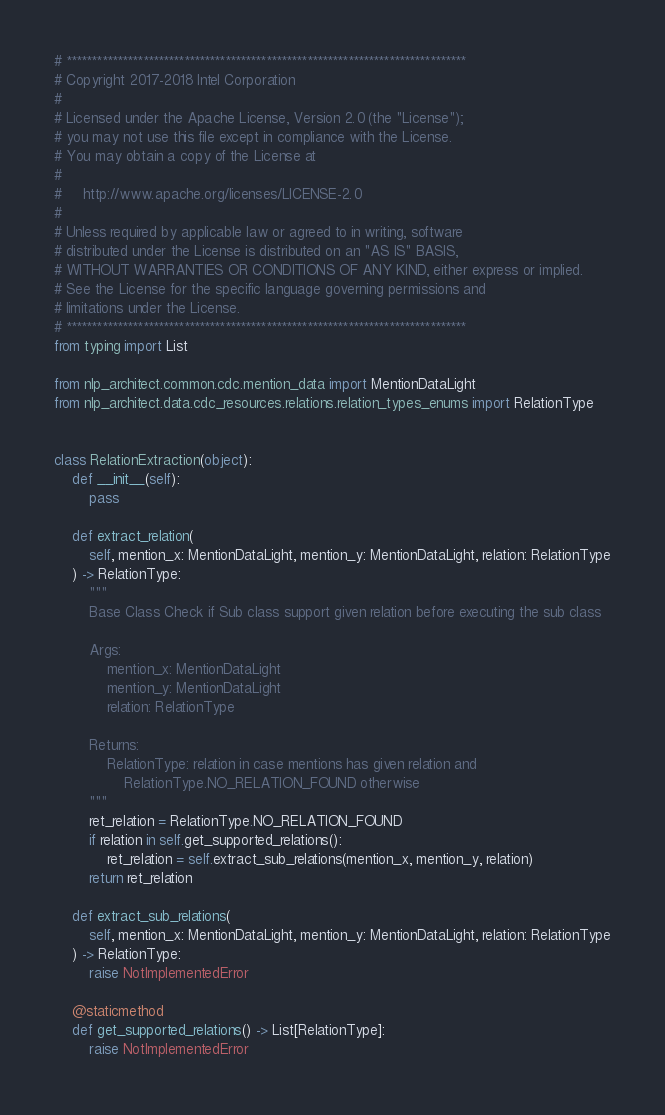Convert code to text. <code><loc_0><loc_0><loc_500><loc_500><_Python_># ******************************************************************************
# Copyright 2017-2018 Intel Corporation
#
# Licensed under the Apache License, Version 2.0 (the "License");
# you may not use this file except in compliance with the License.
# You may obtain a copy of the License at
#
#     http://www.apache.org/licenses/LICENSE-2.0
#
# Unless required by applicable law or agreed to in writing, software
# distributed under the License is distributed on an "AS IS" BASIS,
# WITHOUT WARRANTIES OR CONDITIONS OF ANY KIND, either express or implied.
# See the License for the specific language governing permissions and
# limitations under the License.
# ******************************************************************************
from typing import List

from nlp_architect.common.cdc.mention_data import MentionDataLight
from nlp_architect.data.cdc_resources.relations.relation_types_enums import RelationType


class RelationExtraction(object):
    def __init__(self):
        pass

    def extract_relation(
        self, mention_x: MentionDataLight, mention_y: MentionDataLight, relation: RelationType
    ) -> RelationType:
        """
        Base Class Check if Sub class support given relation before executing the sub class

        Args:
            mention_x: MentionDataLight
            mention_y: MentionDataLight
            relation: RelationType

        Returns:
            RelationType: relation in case mentions has given relation and
                RelationType.NO_RELATION_FOUND otherwise
        """
        ret_relation = RelationType.NO_RELATION_FOUND
        if relation in self.get_supported_relations():
            ret_relation = self.extract_sub_relations(mention_x, mention_y, relation)
        return ret_relation

    def extract_sub_relations(
        self, mention_x: MentionDataLight, mention_y: MentionDataLight, relation: RelationType
    ) -> RelationType:
        raise NotImplementedError

    @staticmethod
    def get_supported_relations() -> List[RelationType]:
        raise NotImplementedError
</code> 